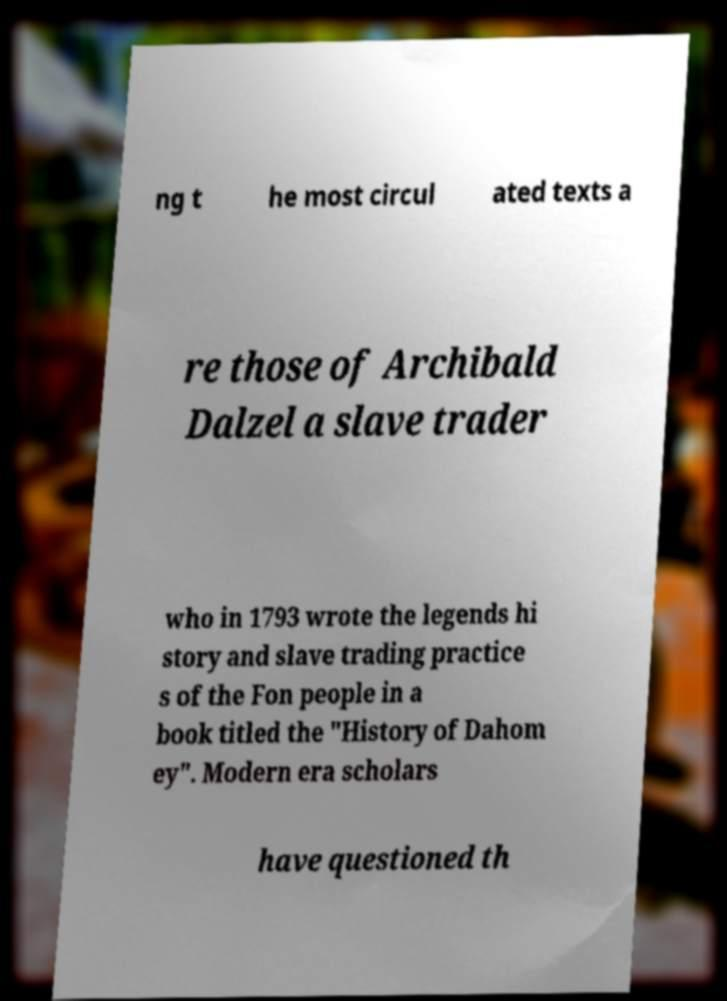For documentation purposes, I need the text within this image transcribed. Could you provide that? ng t he most circul ated texts a re those of Archibald Dalzel a slave trader who in 1793 wrote the legends hi story and slave trading practice s of the Fon people in a book titled the "History of Dahom ey". Modern era scholars have questioned th 